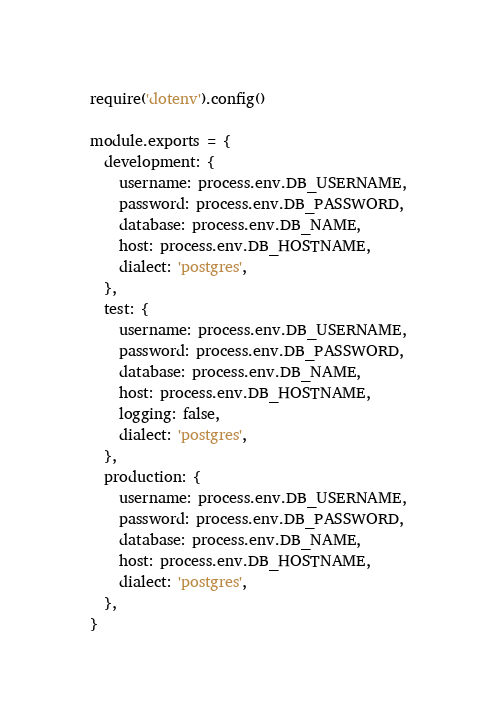<code> <loc_0><loc_0><loc_500><loc_500><_JavaScript_>require('dotenv').config()

module.exports = {
  development: {
    username: process.env.DB_USERNAME,
    password: process.env.DB_PASSWORD,
    database: process.env.DB_NAME,
    host: process.env.DB_HOSTNAME,
    dialect: 'postgres',
  },
  test: {
    username: process.env.DB_USERNAME,
    password: process.env.DB_PASSWORD,
    database: process.env.DB_NAME,
    host: process.env.DB_HOSTNAME,
    logging: false,
    dialect: 'postgres',
  },
  production: {
    username: process.env.DB_USERNAME,
    password: process.env.DB_PASSWORD,
    database: process.env.DB_NAME,
    host: process.env.DB_HOSTNAME,
    dialect: 'postgres',
  },
}
</code> 